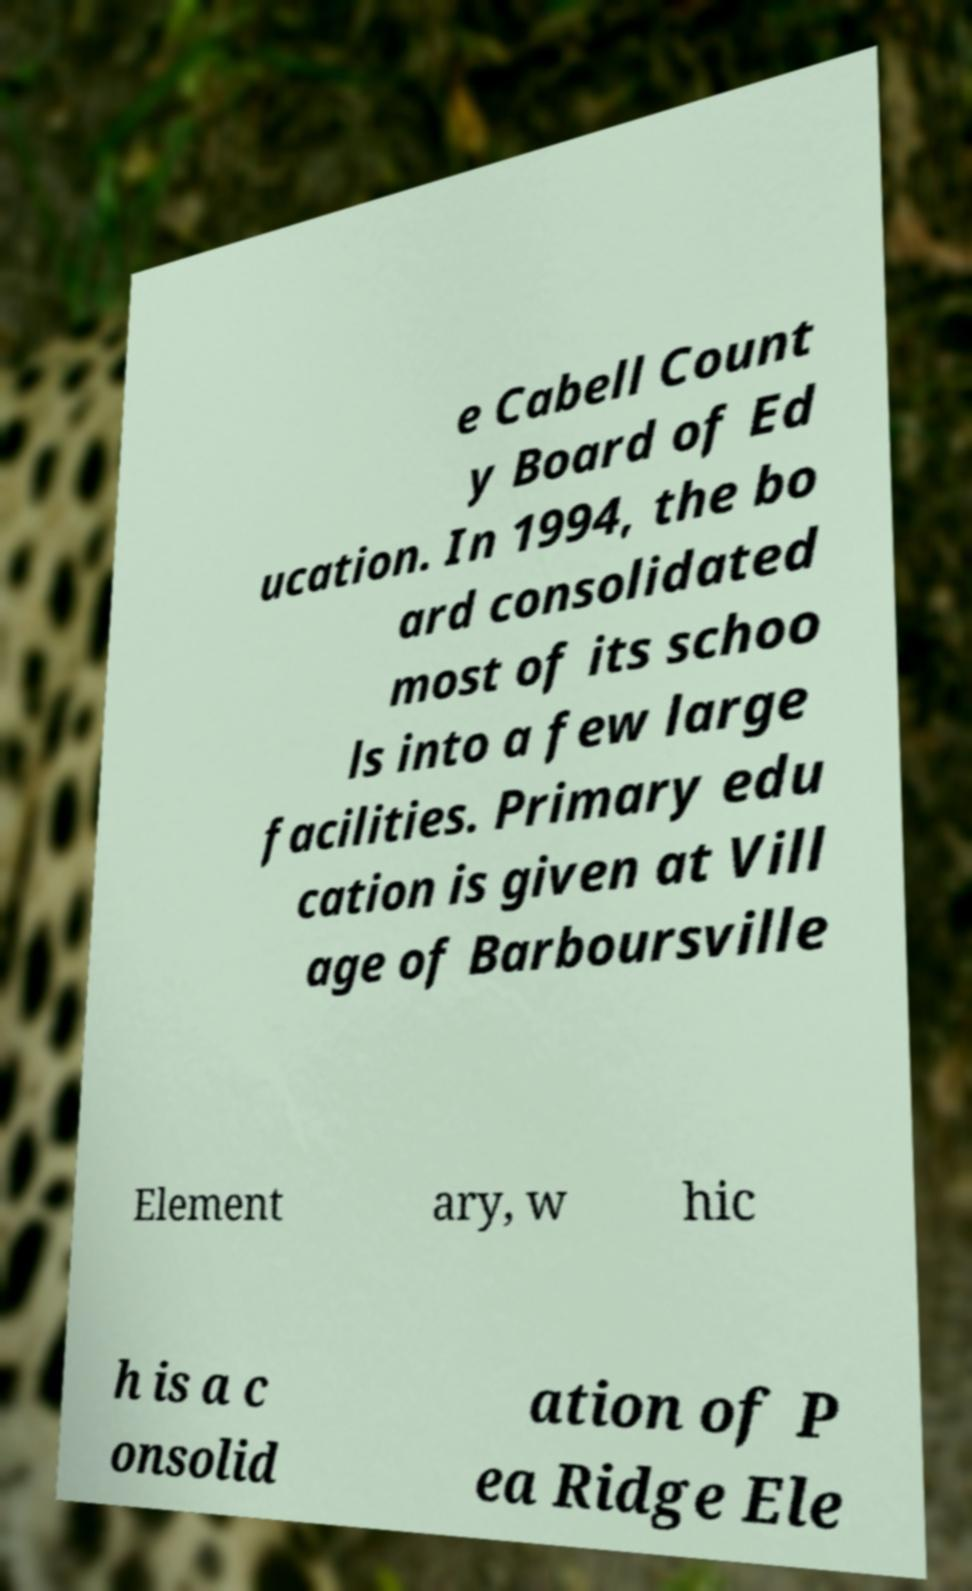Could you assist in decoding the text presented in this image and type it out clearly? e Cabell Count y Board of Ed ucation. In 1994, the bo ard consolidated most of its schoo ls into a few large facilities. Primary edu cation is given at Vill age of Barboursville Element ary, w hic h is a c onsolid ation of P ea Ridge Ele 